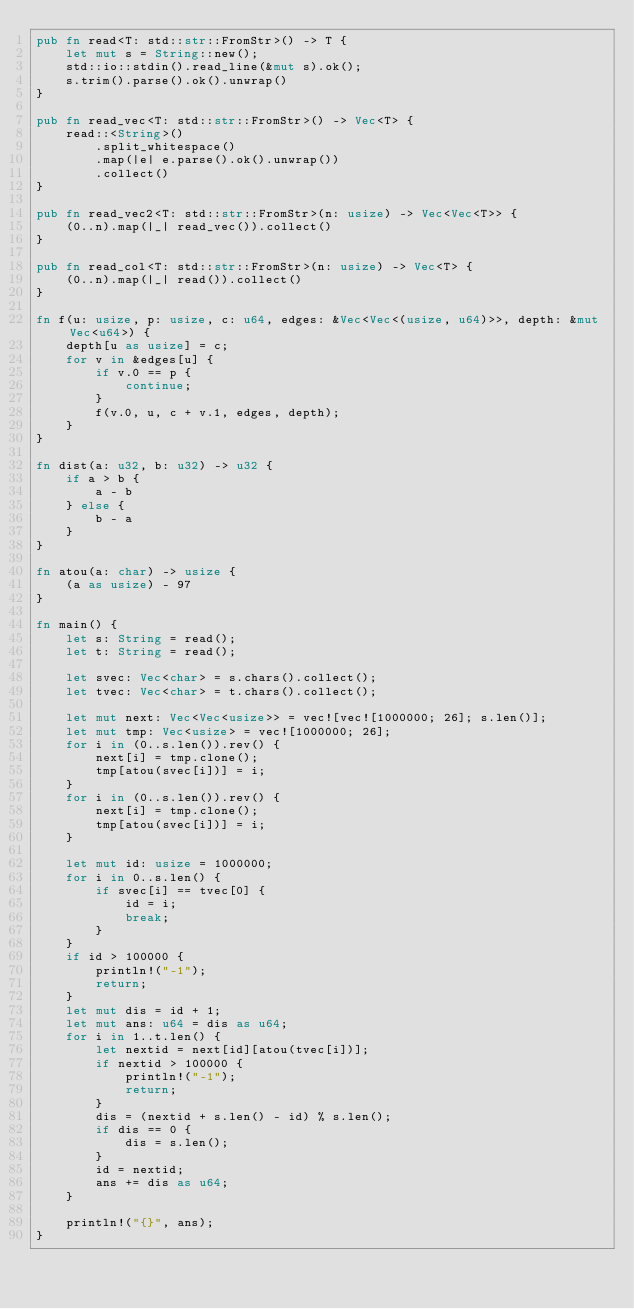<code> <loc_0><loc_0><loc_500><loc_500><_Rust_>pub fn read<T: std::str::FromStr>() -> T {
    let mut s = String::new();
    std::io::stdin().read_line(&mut s).ok();
    s.trim().parse().ok().unwrap()
}

pub fn read_vec<T: std::str::FromStr>() -> Vec<T> {
    read::<String>()
        .split_whitespace()
        .map(|e| e.parse().ok().unwrap())
        .collect()
}

pub fn read_vec2<T: std::str::FromStr>(n: usize) -> Vec<Vec<T>> {
    (0..n).map(|_| read_vec()).collect()
}

pub fn read_col<T: std::str::FromStr>(n: usize) -> Vec<T> {
    (0..n).map(|_| read()).collect()
}

fn f(u: usize, p: usize, c: u64, edges: &Vec<Vec<(usize, u64)>>, depth: &mut Vec<u64>) {
    depth[u as usize] = c;
    for v in &edges[u] {
        if v.0 == p {
            continue;
        }
        f(v.0, u, c + v.1, edges, depth);
    }
}

fn dist(a: u32, b: u32) -> u32 {
    if a > b {
        a - b
    } else {
        b - a
    }
}

fn atou(a: char) -> usize {
    (a as usize) - 97
}

fn main() {
    let s: String = read();
    let t: String = read();

    let svec: Vec<char> = s.chars().collect();
    let tvec: Vec<char> = t.chars().collect();

    let mut next: Vec<Vec<usize>> = vec![vec![1000000; 26]; s.len()];
    let mut tmp: Vec<usize> = vec![1000000; 26];
    for i in (0..s.len()).rev() {
        next[i] = tmp.clone();
        tmp[atou(svec[i])] = i;
    }
    for i in (0..s.len()).rev() {
        next[i] = tmp.clone();
        tmp[atou(svec[i])] = i;
    }

    let mut id: usize = 1000000;
    for i in 0..s.len() {
        if svec[i] == tvec[0] {
            id = i;
            break;
        }
    }
    if id > 100000 {
        println!("-1");
        return;
    }
    let mut dis = id + 1;
    let mut ans: u64 = dis as u64;
    for i in 1..t.len() {
        let nextid = next[id][atou(tvec[i])];
        if nextid > 100000 {
            println!("-1");
            return;
        }
        dis = (nextid + s.len() - id) % s.len();
        if dis == 0 {
            dis = s.len();
        }
        id = nextid;
        ans += dis as u64;
    }

    println!("{}", ans);
}
</code> 